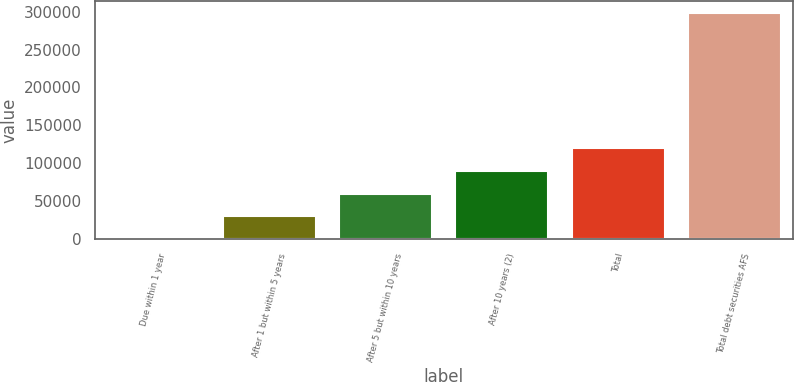Convert chart to OTSL. <chart><loc_0><loc_0><loc_500><loc_500><bar_chart><fcel>Due within 1 year<fcel>After 1 but within 5 years<fcel>After 5 but within 10 years<fcel>After 10 years (2)<fcel>Total<fcel>Total debt securities AFS<nl><fcel>114<fcel>29953.7<fcel>59793.4<fcel>89633.1<fcel>119473<fcel>298511<nl></chart> 